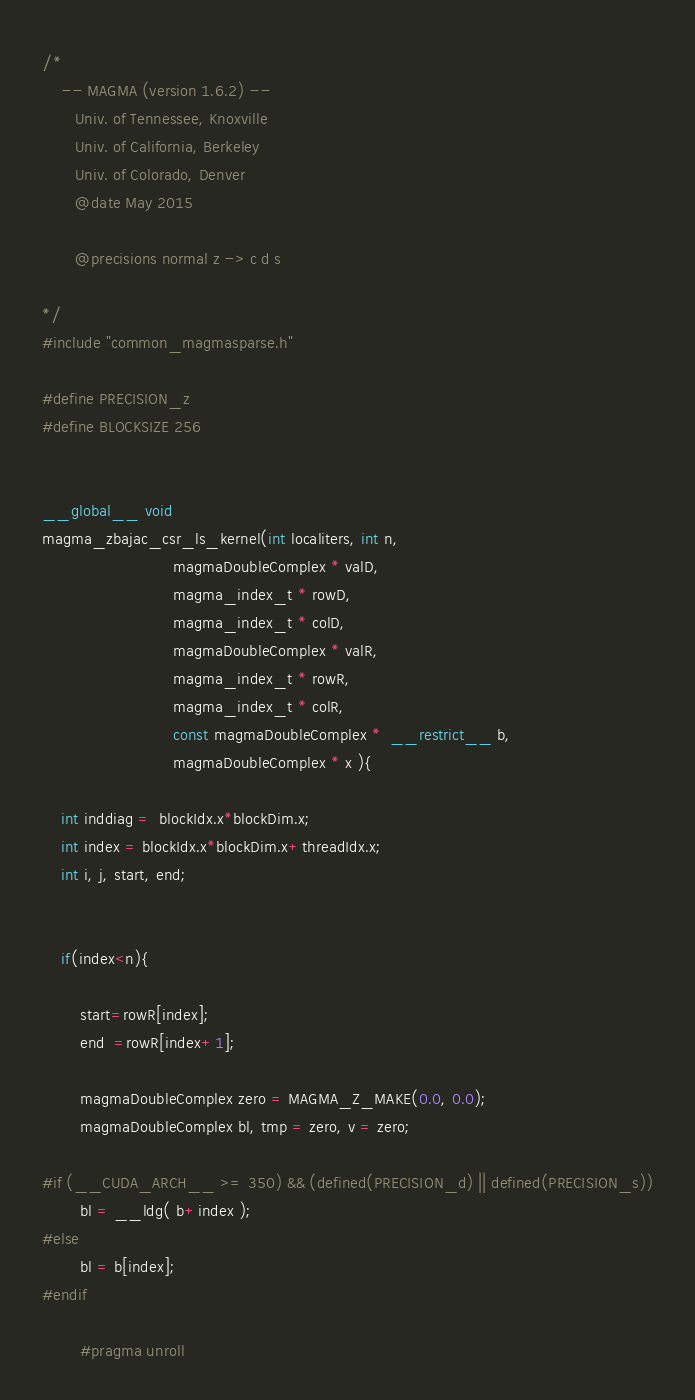<code> <loc_0><loc_0><loc_500><loc_500><_Cuda_>/*
    -- MAGMA (version 1.6.2) --
       Univ. of Tennessee, Knoxville
       Univ. of California, Berkeley
       Univ. of Colorado, Denver
       @date May 2015

       @precisions normal z -> c d s

*/
#include "common_magmasparse.h"

#define PRECISION_z
#define BLOCKSIZE 256


__global__ void
magma_zbajac_csr_ls_kernel(int localiters, int n, 
                            magmaDoubleComplex * valD, 
                            magma_index_t * rowD, 
                            magma_index_t * colD, 
                            magmaDoubleComplex * valR, 
                            magma_index_t * rowR,
                            magma_index_t * colR, 
                            const magmaDoubleComplex *  __restrict__ b,                            
                            magmaDoubleComplex * x ){

    int inddiag =  blockIdx.x*blockDim.x;
    int index = blockIdx.x*blockDim.x+threadIdx.x;
    int i, j, start, end;   


    if(index<n){
    
        start=rowR[index];
        end  =rowR[index+1];

        magmaDoubleComplex zero = MAGMA_Z_MAKE(0.0, 0.0);
        magmaDoubleComplex bl, tmp = zero, v = zero; 

#if (__CUDA_ARCH__ >= 350) && (defined(PRECISION_d) || defined(PRECISION_s))
        bl = __ldg( b+index );
#else
        bl = b[index];
#endif

        #pragma unroll</code> 